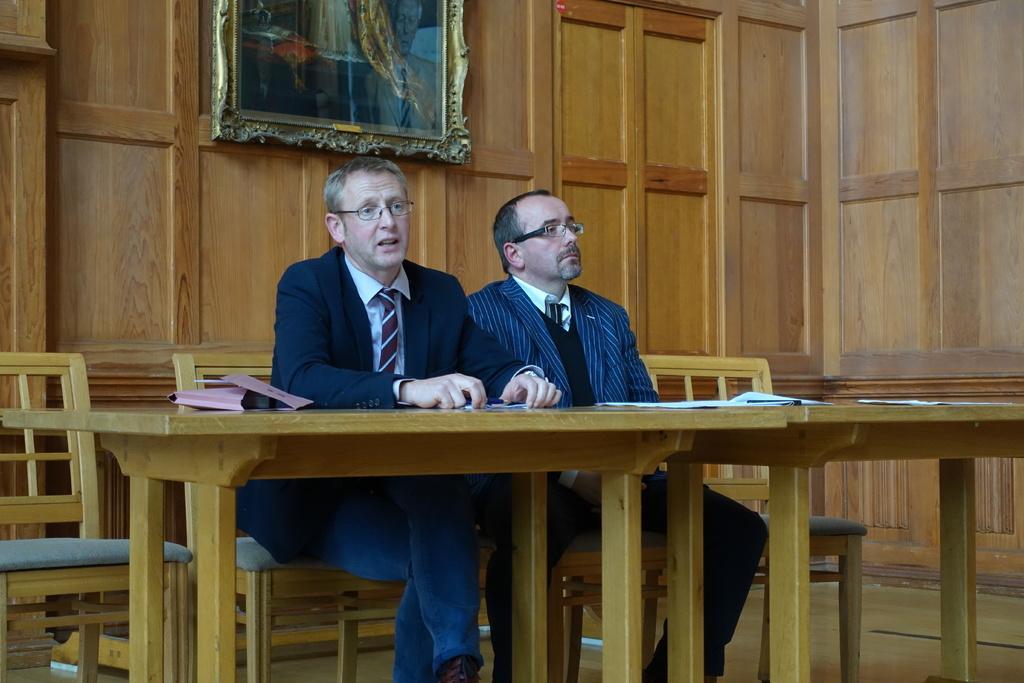Can you describe this image briefly? These two persons sitting on the chair. We can see paper,pen on the table. This person holding paper. On the background we can see frame,wall. 